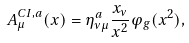<formula> <loc_0><loc_0><loc_500><loc_500>A _ { \mu } ^ { C I , a } ( x ) = \eta ^ { a } _ { \nu \mu } \frac { x _ { \nu } } { x ^ { 2 } } \varphi _ { g } ( x ^ { 2 } ) ,</formula> 